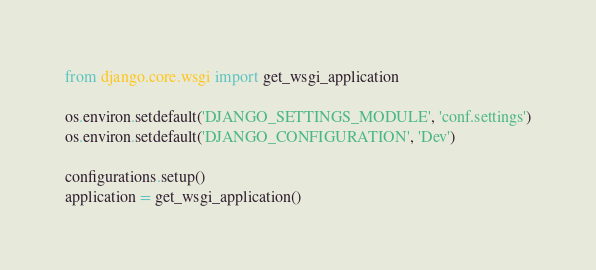Convert code to text. <code><loc_0><loc_0><loc_500><loc_500><_Python_>from django.core.wsgi import get_wsgi_application

os.environ.setdefault('DJANGO_SETTINGS_MODULE', 'conf.settings')
os.environ.setdefault('DJANGO_CONFIGURATION', 'Dev')

configurations.setup()
application = get_wsgi_application()
</code> 